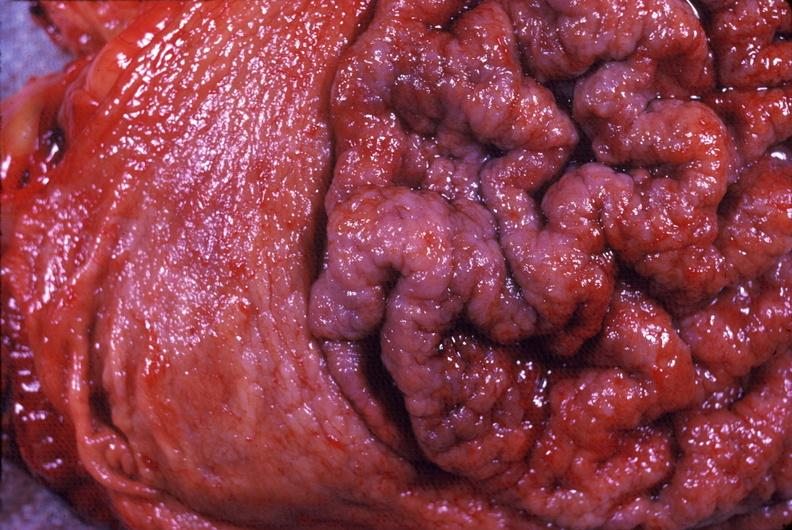does lymphangiomatosis generalized show stomach, giant rugose hypertrophy?
Answer the question using a single word or phrase. No 